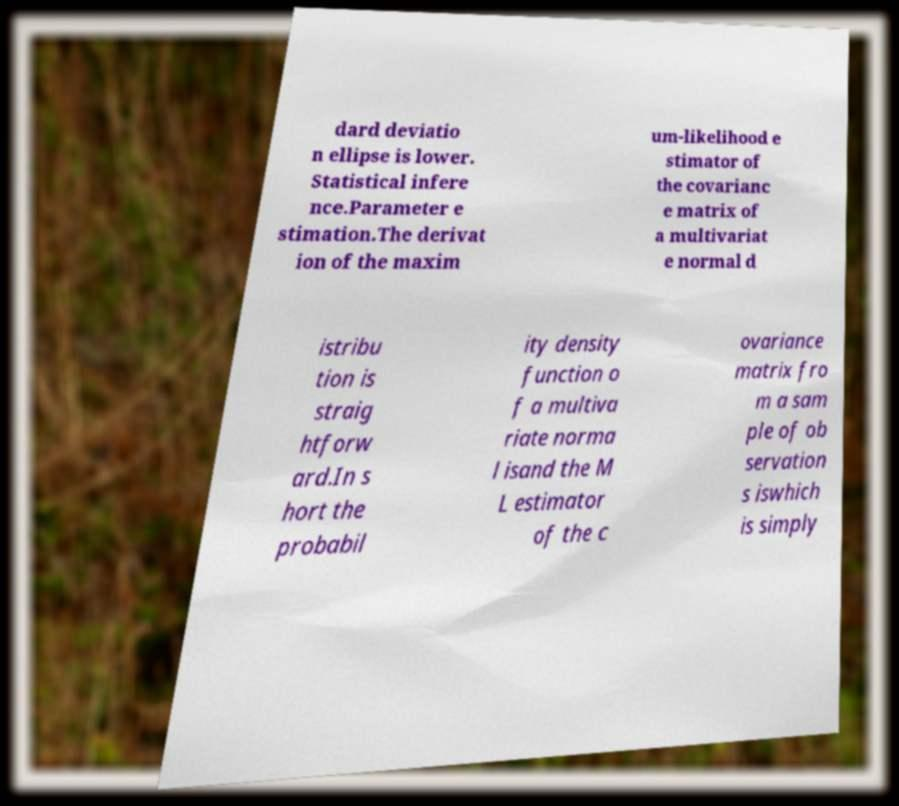Please identify and transcribe the text found in this image. dard deviatio n ellipse is lower. Statistical infere nce.Parameter e stimation.The derivat ion of the maxim um-likelihood e stimator of the covarianc e matrix of a multivariat e normal d istribu tion is straig htforw ard.In s hort the probabil ity density function o f a multiva riate norma l isand the M L estimator of the c ovariance matrix fro m a sam ple of ob servation s iswhich is simply 